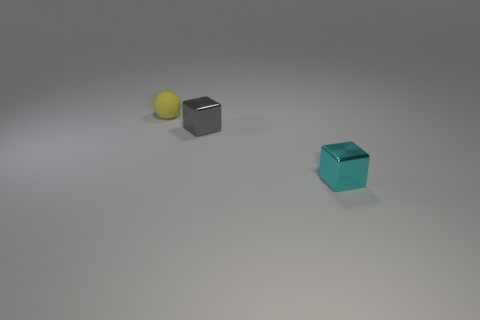Add 2 big blue matte things. How many objects exist? 5 Subtract all blocks. How many objects are left? 1 Subtract 0 cyan balls. How many objects are left? 3 Subtract all yellow rubber spheres. Subtract all small yellow matte objects. How many objects are left? 1 Add 2 cubes. How many cubes are left? 4 Add 3 tiny gray rubber balls. How many tiny gray rubber balls exist? 3 